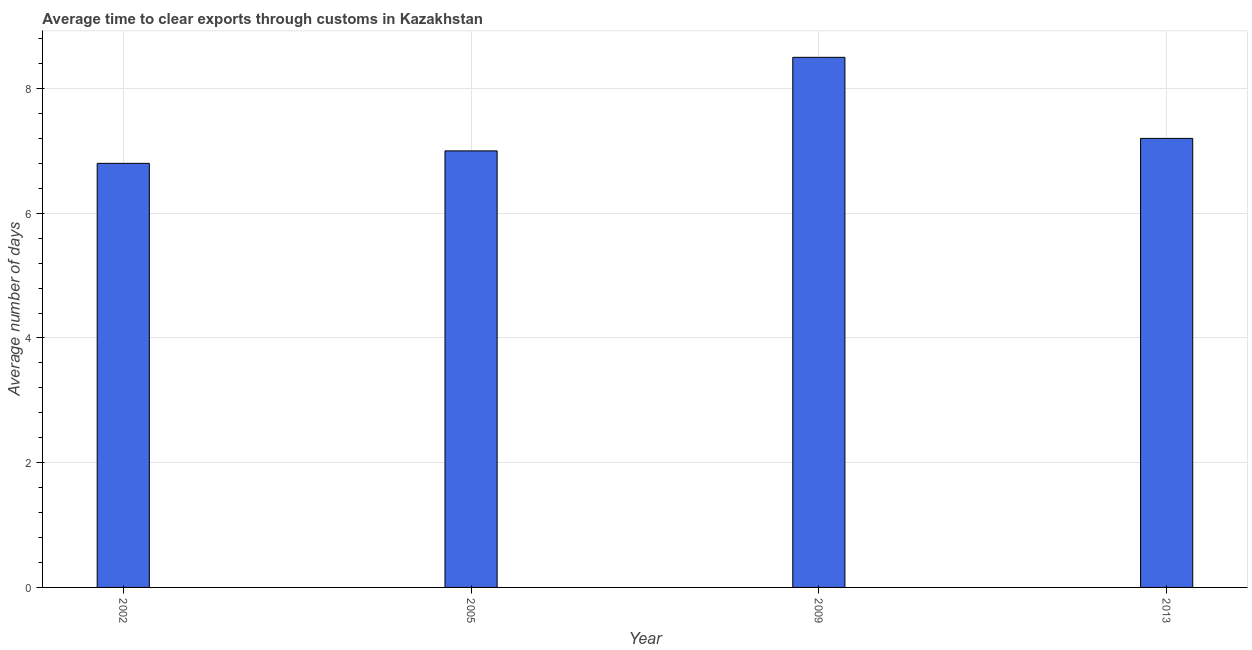Does the graph contain grids?
Provide a succinct answer. Yes. What is the title of the graph?
Ensure brevity in your answer.  Average time to clear exports through customs in Kazakhstan. What is the label or title of the Y-axis?
Your answer should be compact. Average number of days. What is the time to clear exports through customs in 2013?
Your answer should be compact. 7.2. In which year was the time to clear exports through customs maximum?
Ensure brevity in your answer.  2009. In which year was the time to clear exports through customs minimum?
Your response must be concise. 2002. What is the sum of the time to clear exports through customs?
Ensure brevity in your answer.  29.5. What is the difference between the time to clear exports through customs in 2002 and 2013?
Keep it short and to the point. -0.4. What is the average time to clear exports through customs per year?
Keep it short and to the point. 7.38. What is the median time to clear exports through customs?
Make the answer very short. 7.1. Do a majority of the years between 2002 and 2005 (inclusive) have time to clear exports through customs greater than 3.2 days?
Your answer should be compact. Yes. What is the ratio of the time to clear exports through customs in 2005 to that in 2009?
Your answer should be very brief. 0.82. Is the difference between the time to clear exports through customs in 2002 and 2013 greater than the difference between any two years?
Give a very brief answer. No. Is the sum of the time to clear exports through customs in 2005 and 2013 greater than the maximum time to clear exports through customs across all years?
Keep it short and to the point. Yes. What is the difference between the highest and the lowest time to clear exports through customs?
Provide a succinct answer. 1.7. How many bars are there?
Give a very brief answer. 4. How many years are there in the graph?
Your answer should be very brief. 4. What is the difference between two consecutive major ticks on the Y-axis?
Provide a short and direct response. 2. Are the values on the major ticks of Y-axis written in scientific E-notation?
Your answer should be compact. No. What is the Average number of days in 2013?
Provide a short and direct response. 7.2. What is the difference between the Average number of days in 2002 and 2005?
Your answer should be very brief. -0.2. What is the difference between the Average number of days in 2002 and 2009?
Your answer should be compact. -1.7. What is the difference between the Average number of days in 2002 and 2013?
Your response must be concise. -0.4. What is the difference between the Average number of days in 2005 and 2009?
Your answer should be very brief. -1.5. What is the ratio of the Average number of days in 2002 to that in 2013?
Keep it short and to the point. 0.94. What is the ratio of the Average number of days in 2005 to that in 2009?
Make the answer very short. 0.82. What is the ratio of the Average number of days in 2009 to that in 2013?
Make the answer very short. 1.18. 